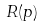Convert formula to latex. <formula><loc_0><loc_0><loc_500><loc_500>R ( p )</formula> 